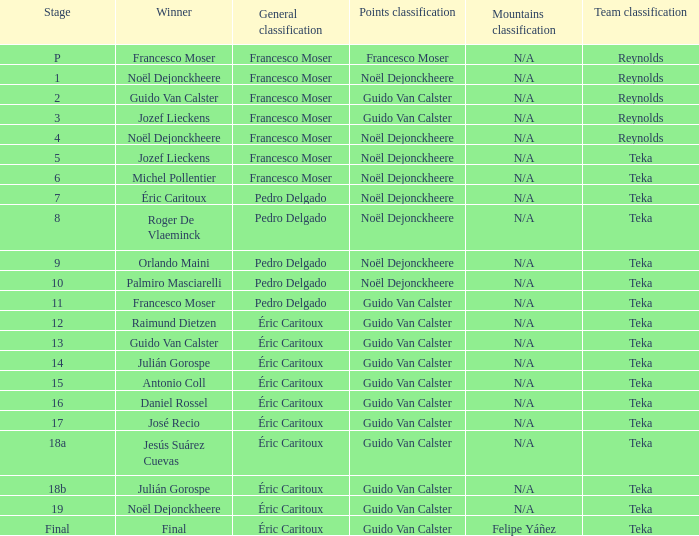Specify the points classification for stage 18b. Guido Van Calster. 